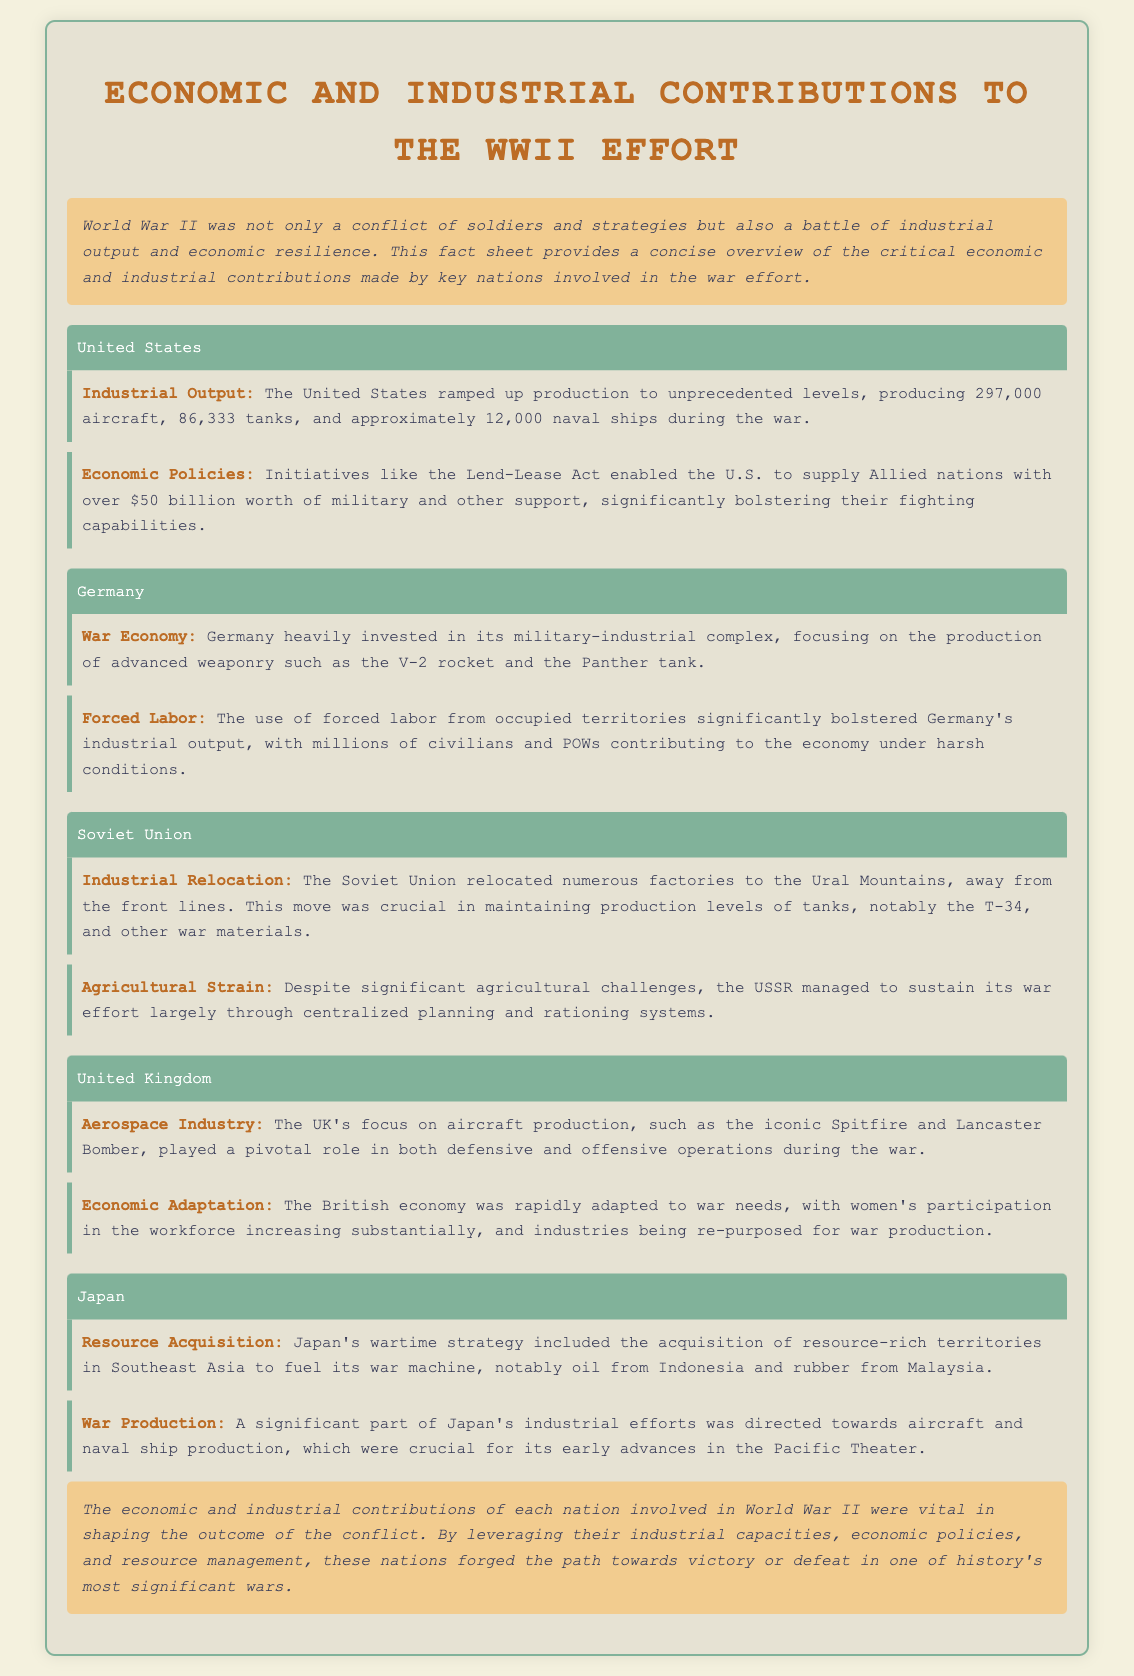what was the total aircraft production by the United States? The total aircraft production is specifically stated as 297,000 in the document.
Answer: 297,000 what major economic policy did the United States implement to support Allied nations? The document mentions the Lend-Lease Act as a significant initiative by the U.S. to support Allies.
Answer: Lend-Lease Act how did Germany's use of forced labor impact its industrial output? The document states that forced labor significantly bolstered Germany's industrial output with millions contributing.
Answer: significantly bolstered what critical material did the Soviet Union strive to maintain production of during the war? The T-34 tank is specifically mentioned as a key product of Soviet industrial efforts.
Answer: T-34 which British aircraft was pivotal in defensive and offensive operations? The iconic Spitfire is mentioned as a pivotal aircraft in the UK's operations during the war.
Answer: Spitfire why did Japan acquire territories in Southeast Asia? The document explains Japan's acquisition was aimed at fueling its war machine with resources.
Answer: to fuel its war machine what role did women play in the British economy during the war? The document notes that women's participation in the workforce increased substantially during the war.
Answer: increased substantially which country relocated factories to maintain its war production? The Soviet Union is specifically noted for relocating numerous factories to the Ural Mountains.
Answer: Soviet Union what was a key aspect of Japan's war production efforts? The document indicates that a significant part of Japan's efforts was directed towards aircraft and naval ship production.
Answer: aircraft and naval ship production 